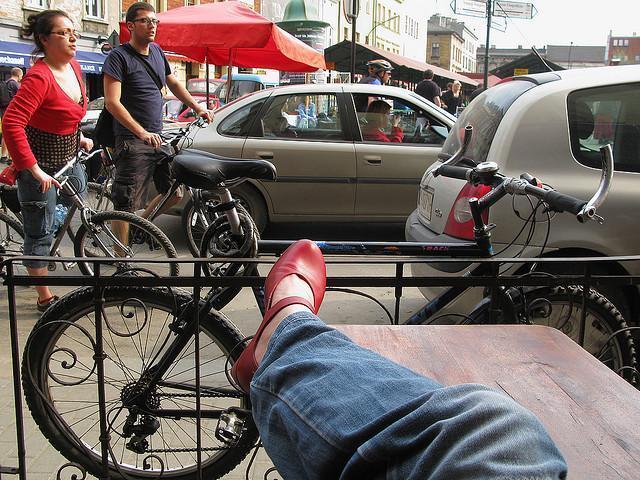How is doing what the photo taker is doing with their leg considered?
Select the accurate answer and provide justification: `Answer: choice
Rationale: srationale.`
Options: Spiritual, slightly rude, dangerous, perfectly normal. Answer: slightly rude.
Rationale: A person has their foot and leg resting on a table. 